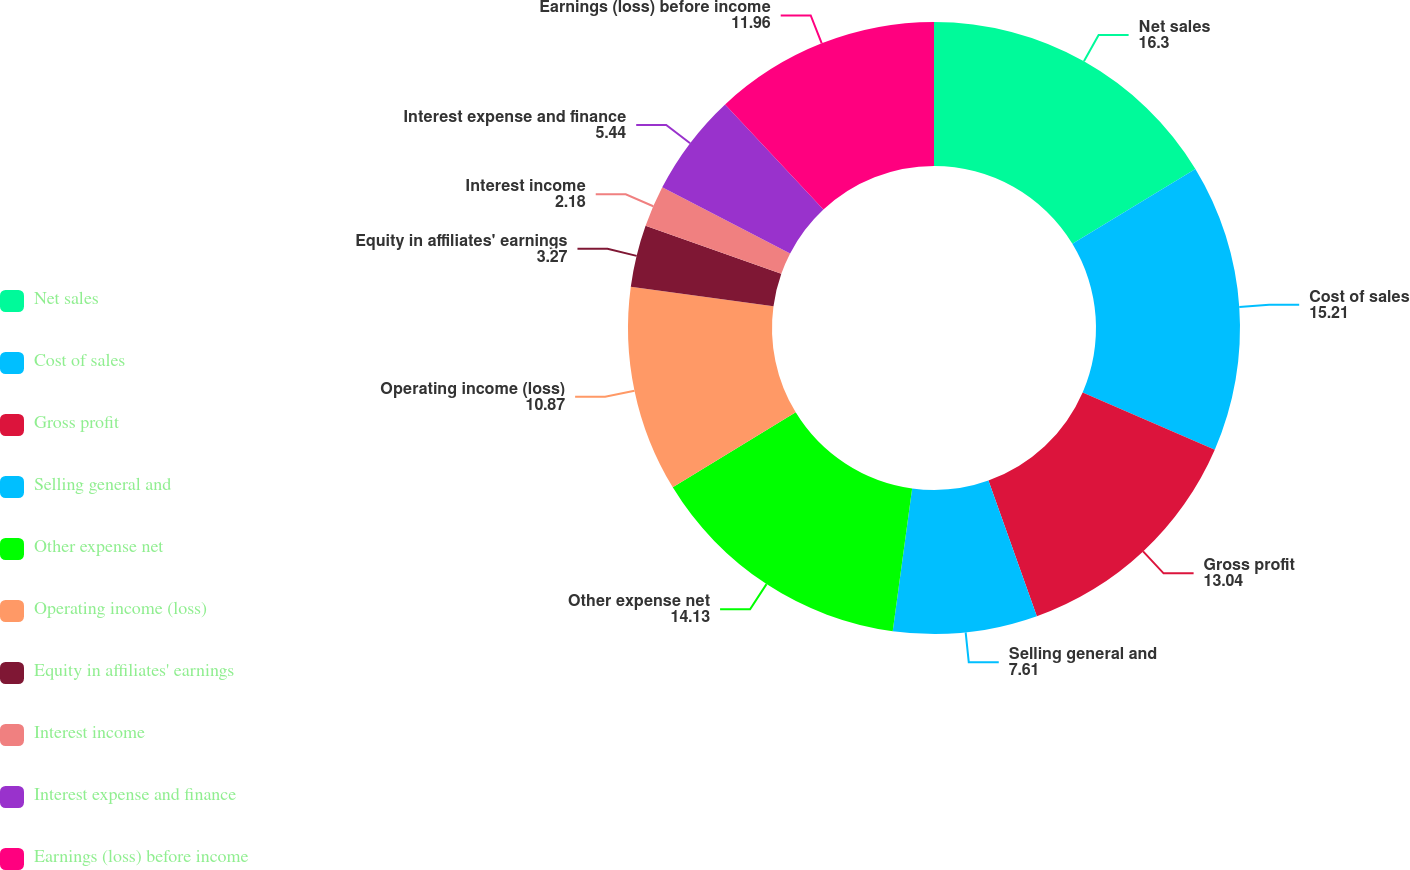Convert chart to OTSL. <chart><loc_0><loc_0><loc_500><loc_500><pie_chart><fcel>Net sales<fcel>Cost of sales<fcel>Gross profit<fcel>Selling general and<fcel>Other expense net<fcel>Operating income (loss)<fcel>Equity in affiliates' earnings<fcel>Interest income<fcel>Interest expense and finance<fcel>Earnings (loss) before income<nl><fcel>16.3%<fcel>15.21%<fcel>13.04%<fcel>7.61%<fcel>14.13%<fcel>10.87%<fcel>3.27%<fcel>2.18%<fcel>5.44%<fcel>11.96%<nl></chart> 